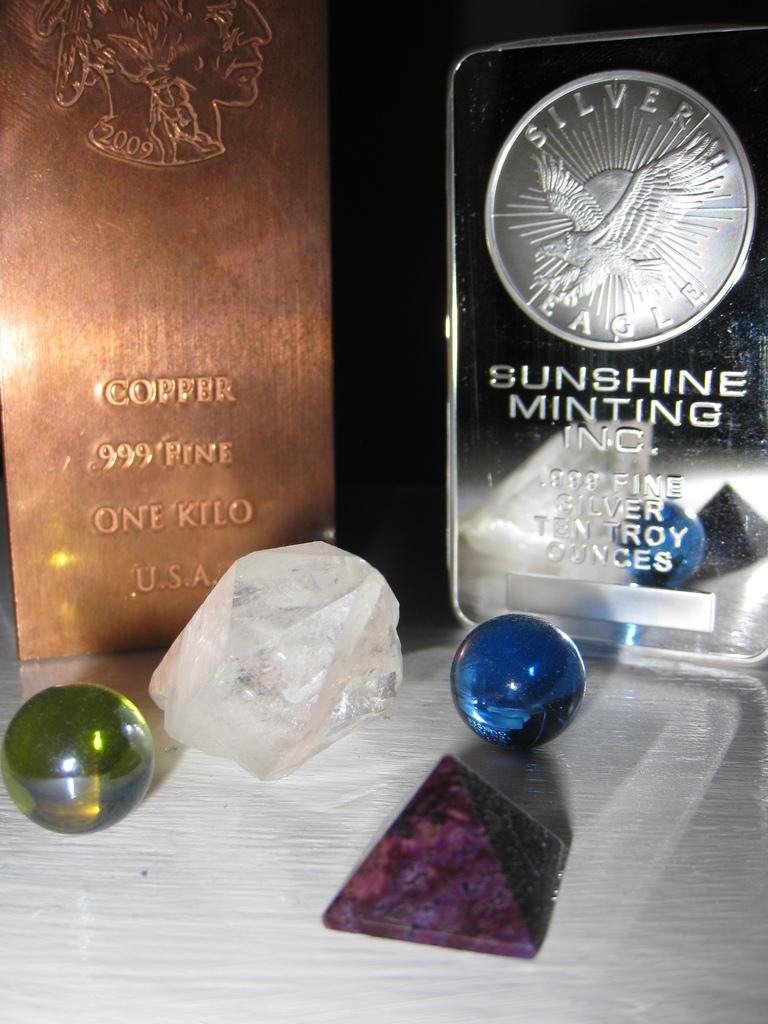<image>
Create a compact narrative representing the image presented. Some marbles and crystals are displayed in front of a Sunshine Minting coin. 